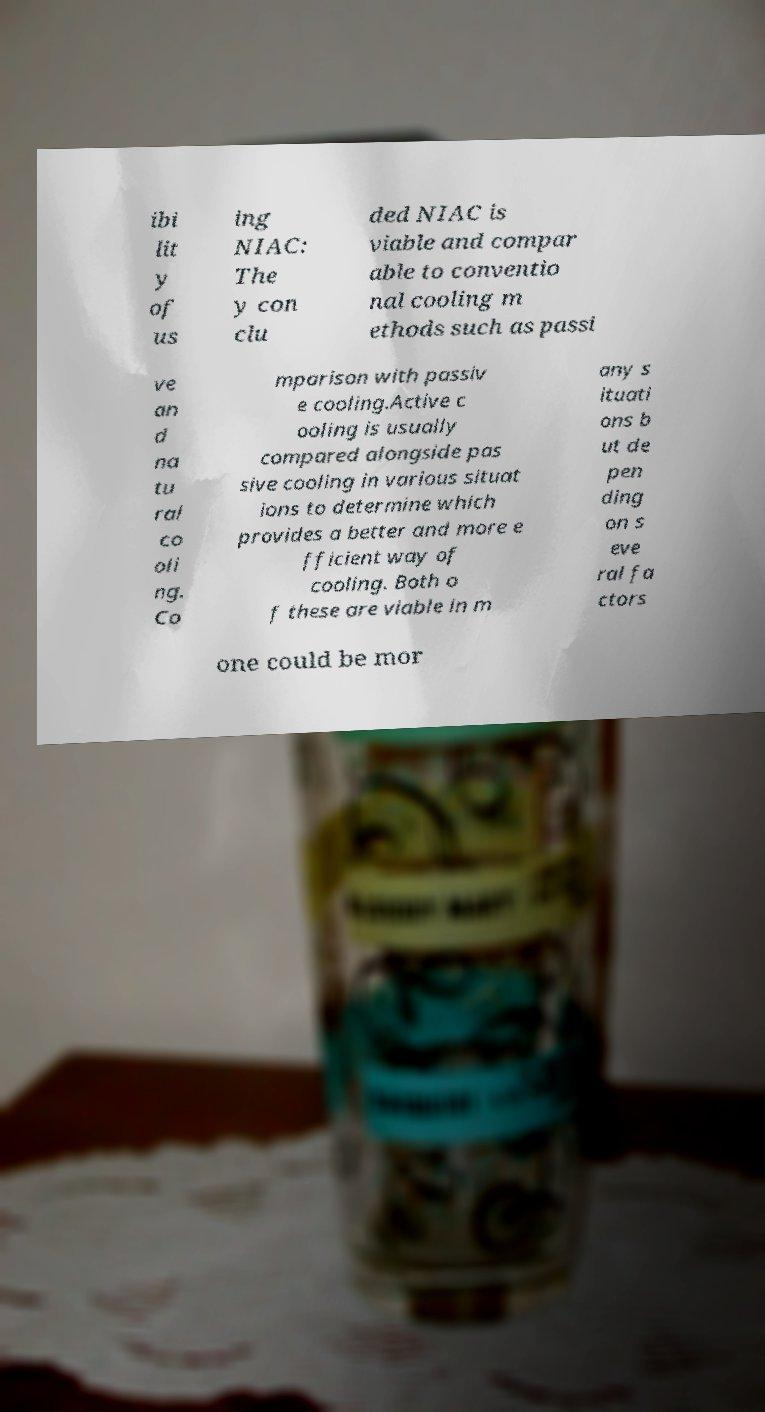For documentation purposes, I need the text within this image transcribed. Could you provide that? ibi lit y of us ing NIAC: The y con clu ded NIAC is viable and compar able to conventio nal cooling m ethods such as passi ve an d na tu ral co oli ng. Co mparison with passiv e cooling.Active c ooling is usually compared alongside pas sive cooling in various situat ions to determine which provides a better and more e fficient way of cooling. Both o f these are viable in m any s ituati ons b ut de pen ding on s eve ral fa ctors one could be mor 